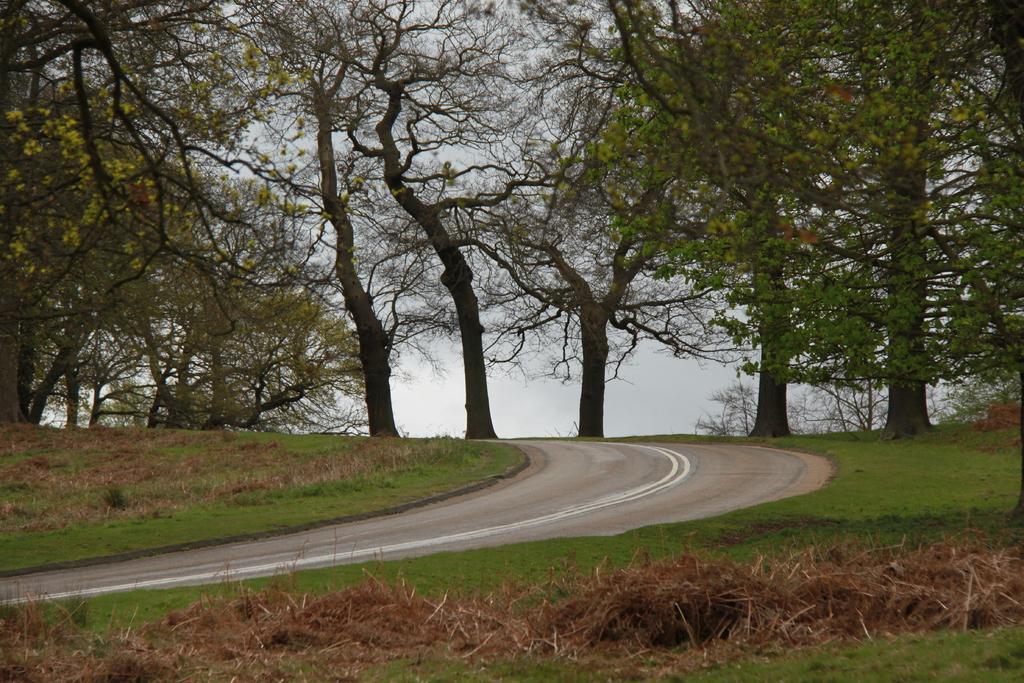How would you summarize this image in a sentence or two? This is the picture of a road. In this image there are trees. At the top there is sky. At the bottom there is a road and there is grass. 